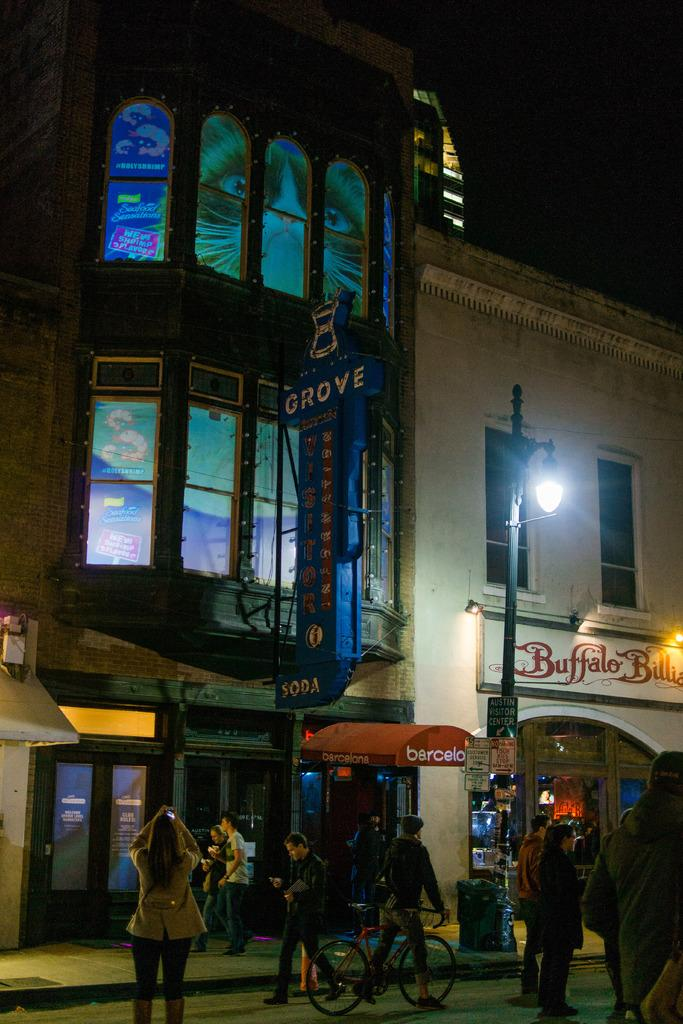What type of structures can be seen in the image? There are buildings in the image. What is the large sign-like object in the image? There is a hoarding board in the image. Can you describe the source of light in the image? There is a light in the image. How many people are present in the image? Two persons are standing, two persons are walking, and one person is riding a bicycle in the image, making a total of five people. What type of pathway is visible in the image? There is a road in the image. What advice does the grandmother give to the queen in the image? There is no grandmother or queen present in the image. What type of test is being conducted on the road in the image? There is no test being conducted on the road in the image. 